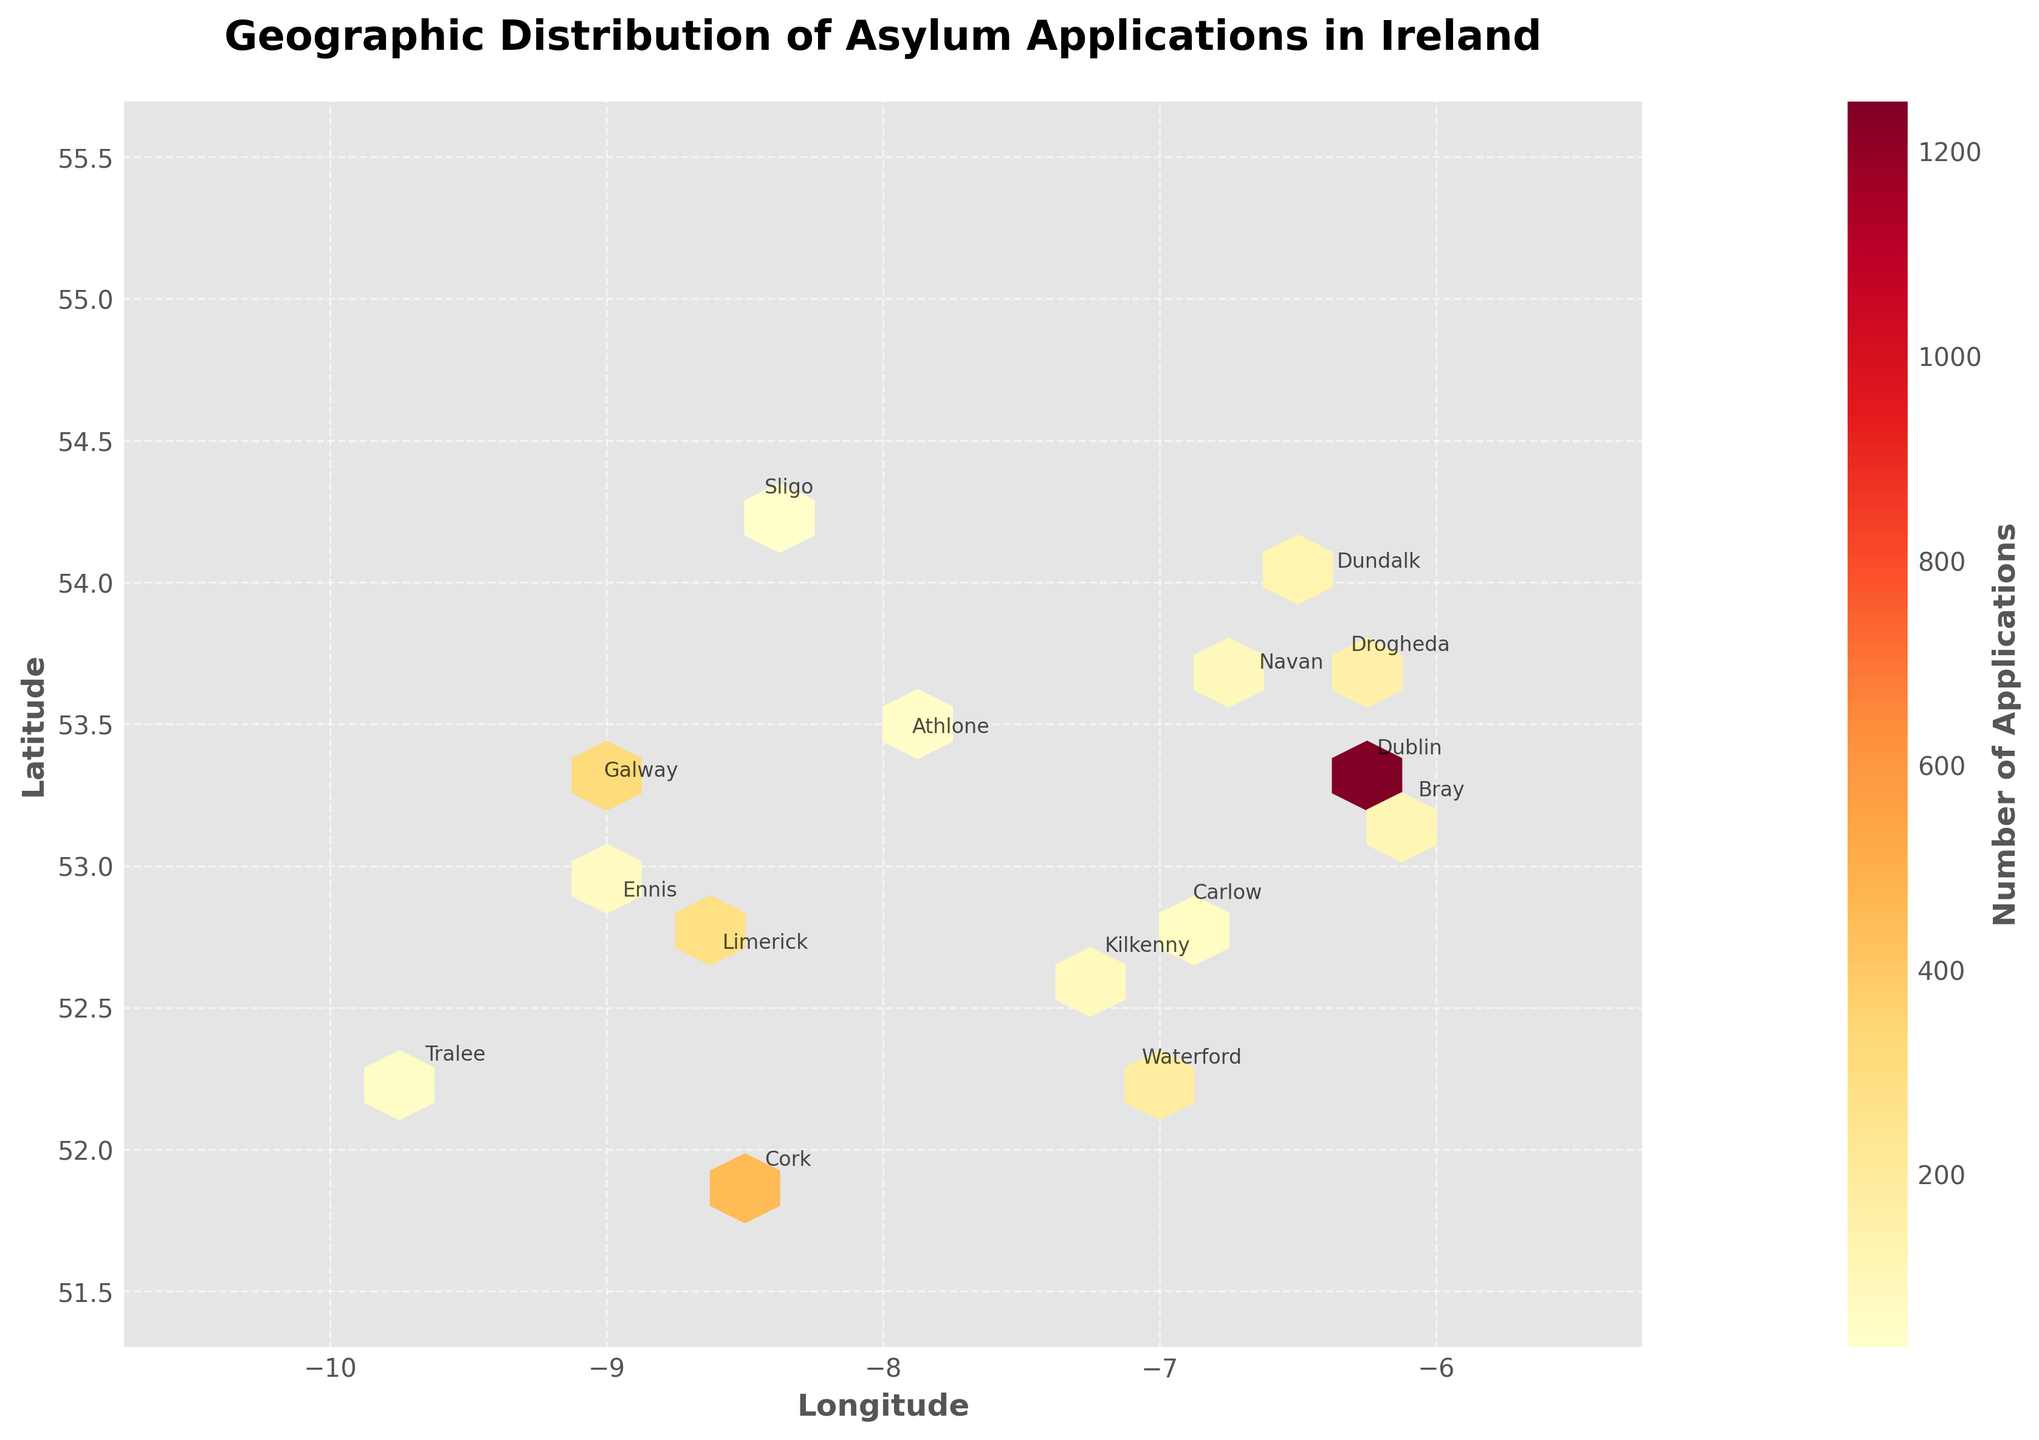What is the title of the plot? The title of the plot is usually located at the top and provides a summary of the data being visualized. In this case, the title reads "Geographic Distribution of Asylum Applications in Ireland".
Answer: Geographic Distribution of Asylum Applications in Ireland What do the x-axis and y-axis represent? The x-axis represents the longitude, while the y-axis represents the latitude. This is usually stated near the respective axes.
Answer: Longitude and Latitude Which county has the highest concentration of asylum applications? The hexbin plot shows the highest concentration in the Dublin area, which is indicated by the darkest hexbin color. Dublin also has 1250 applications, the highest in the dataset.
Answer: Dublin How many counties have more than 100 asylum applications? By checking the annotations and their corresponding data points, we can see that Dublin, Cork, Galway, Limerick, Waterford, Drogheda, and Dundalk have more than 100 applications.
Answer: 7 counties Which counties have fewer than 100 applications? From the given plot annotations, Bray, Navan, Kilkenny, Ennis, Carlow, Tralee, Athlone, and Sligo have fewer than 100 applications.
Answer: 8 counties What label is used for the color bar? The color bar label explains the range of the data being visualized. It reads "Number of Applications".
Answer: Number of Applications How does the number of applications in Cork compare to that in Galway? To compare Cork and Galway, we look at their annotations. Cork has 450 applications, while Galway has 320 applications. Thus, Cork has more applications than Galway.
Answer: Cork has more applications Explain the concentration pattern of asylum applications across Ireland. The hexbin plot shows higher concentrations of applications in urban areas like Dublin, Cork, Galway, and Limerick, evident by the darker hexagons. The annotations confirm this with higher application numbers in these cities.
Answer: Higher in urban areas What's the range of the longitude values depicted in the plot? The longitude values' range is given by the axis or the plot's extent, which goes from -10.5 to -5.5.
Answer: -10.5 to -5.5 Which county is located farthest north in the plot? The county farthest north can be determined by examining the latitudinal values. Dundalk (54.0088) is the northernmost point according to the dataset used to generate the plot.
Answer: Dundalk 